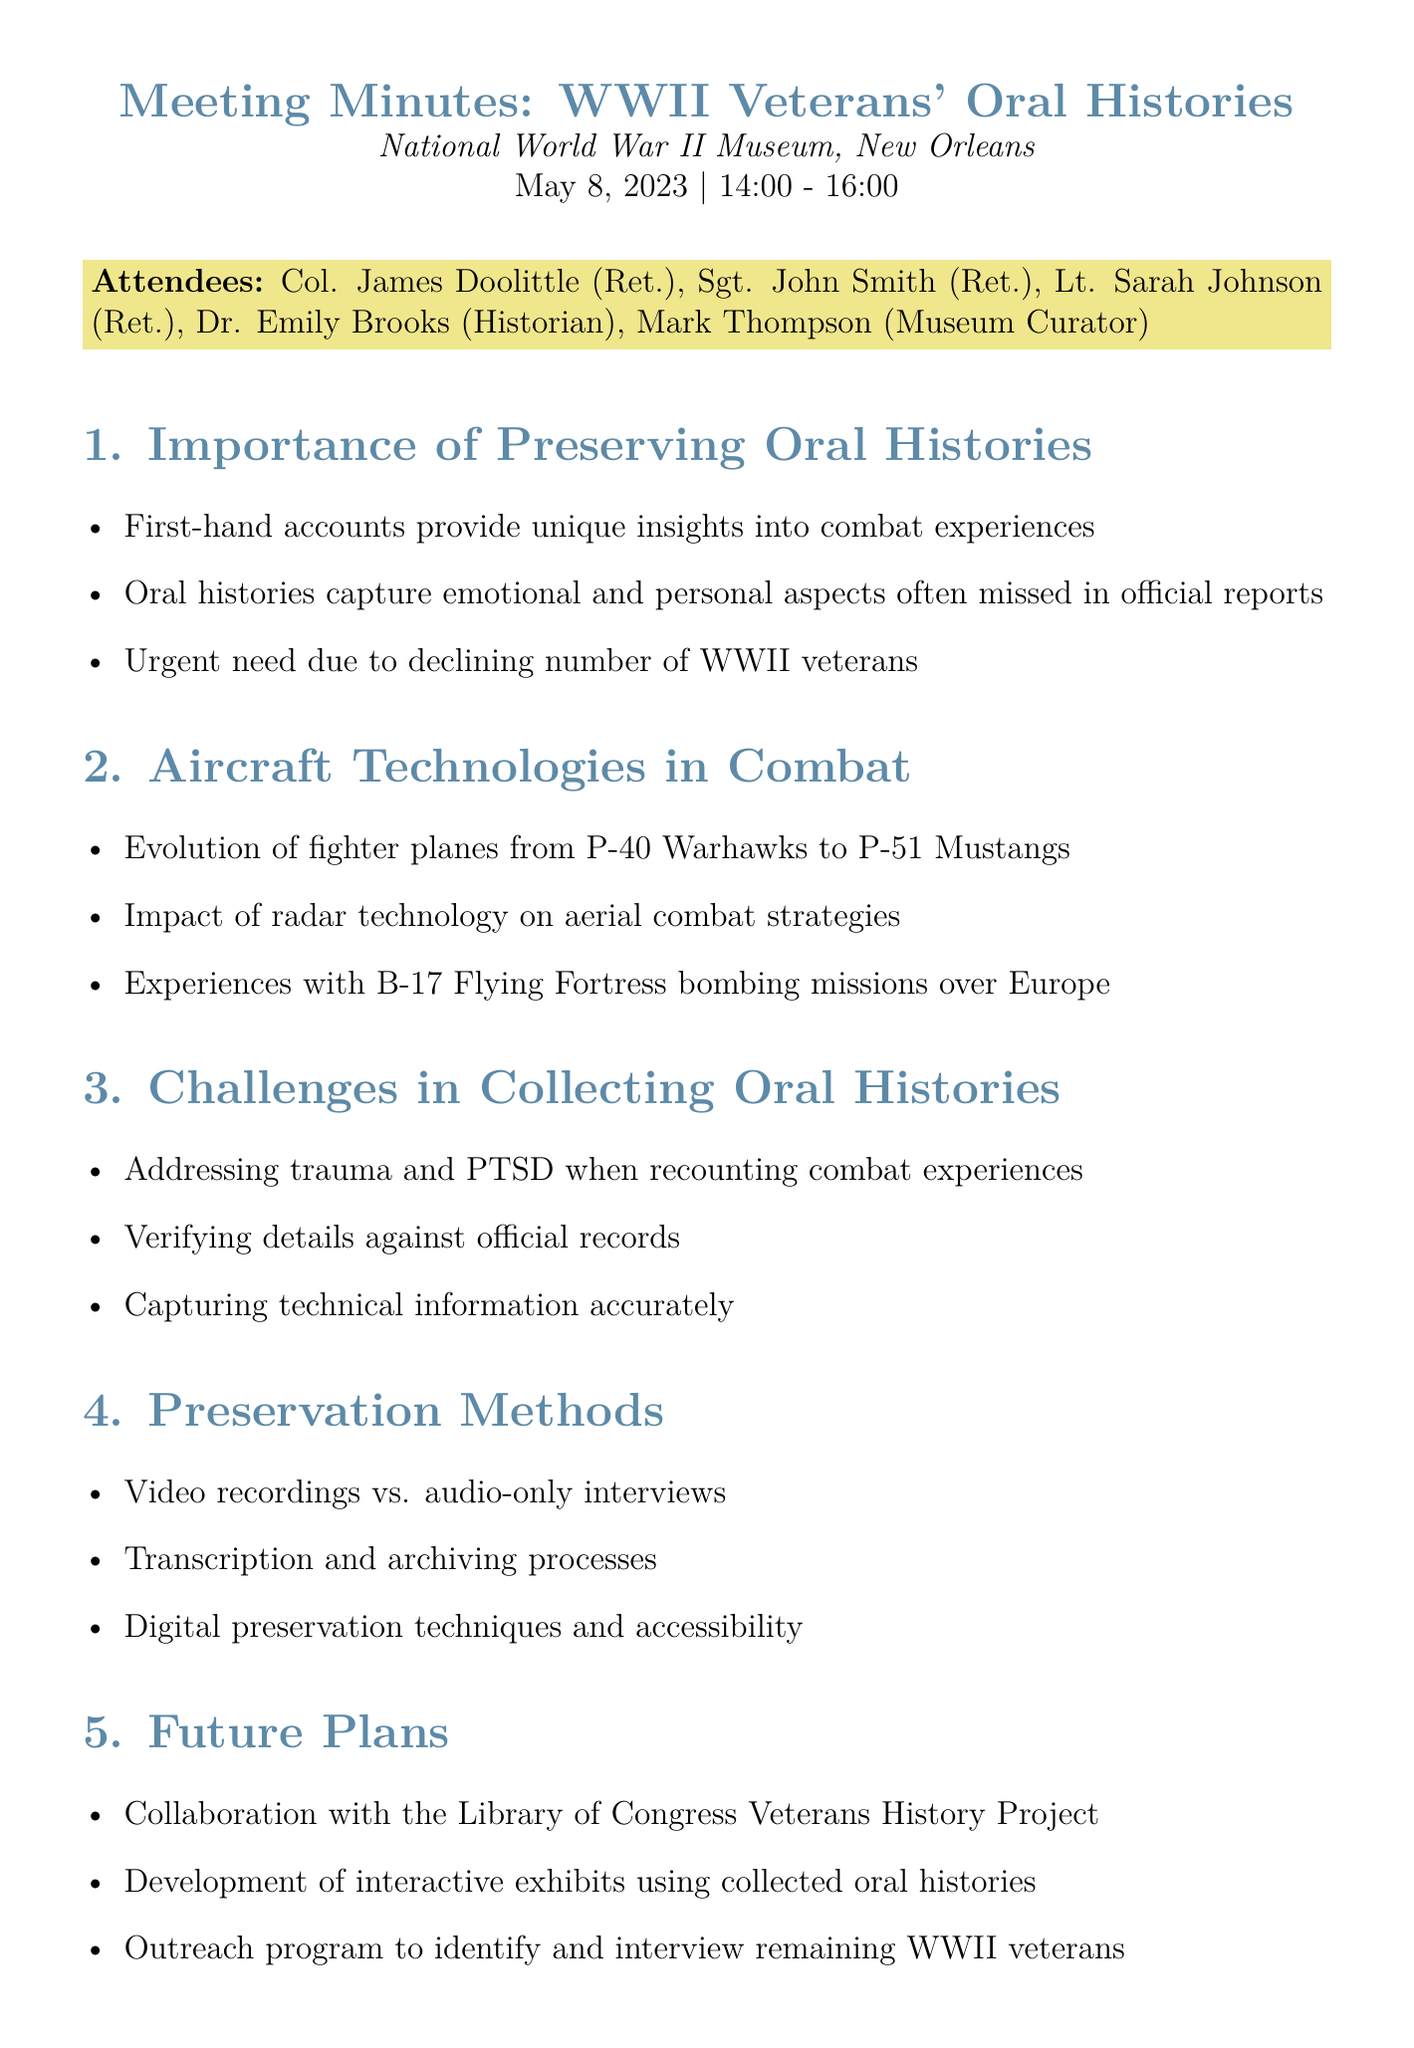What date was the meeting held? The date of the meeting is explicitly mentioned in the document, which is May 8, 2023.
Answer: May 8, 2023 Who chaired the meeting? The document lists attendees but does not specify a chair, though it includes notable veterans and a historian.
Answer: Not specified What was one of the challenges discussed in collecting oral histories? The document lists challenges, including trauma and PTSD, verifying details against official records, and technical information accuracy.
Answer: Addressing trauma and PTSD What aircraft technology improvement was discussed during the meeting? The document specifically mentions the evolution of fighter planes during the discussion on aircraft technologies in combat.
Answer: Evolution of fighter planes What organization plans to collaborate on preserving oral histories? The document indicates a future collaboration with the Library of Congress Veterans History Project.
Answer: Library of Congress Veterans History Project How long did the meeting last? The meeting time stated in the document was from 14:00 to 16:00, which covers a 2-hour duration.
Answer: 2 hours What is one method of preservation mentioned in the meeting? The document includes various methods of preservation like video recordings, audio-only interviews, and transcription processes.
Answer: Video recordings What is one action item decided during the meeting? The document includes action items such as scheduling follow-up interviews and investigating funding options for the oral history program.
Answer: Schedule follow-up interviews with attending veterans 